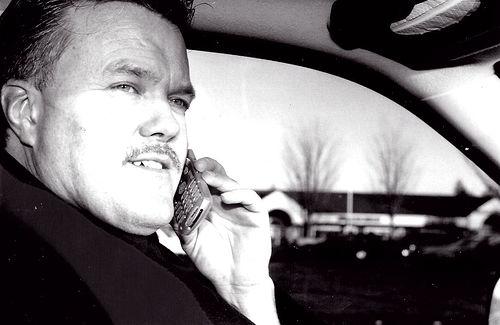Does the man have a mustache?
Give a very brief answer. Yes. Is the man talking?
Quick response, please. Yes. Is the man holding a phone?
Be succinct. Yes. 